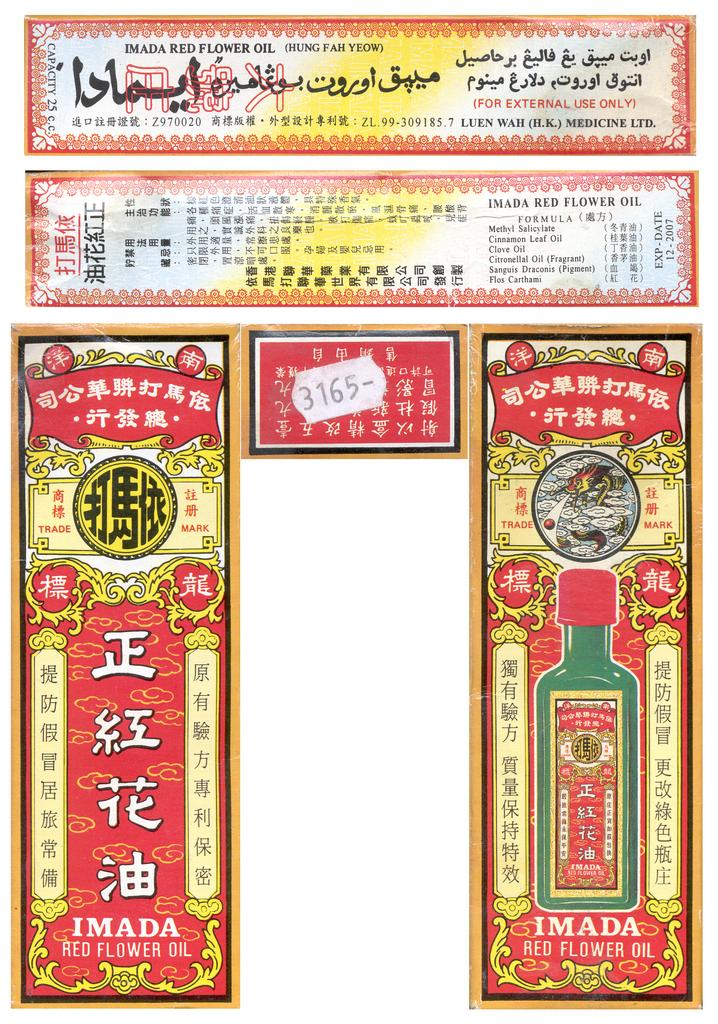<image>
Give a short and clear explanation of the subsequent image. Imada Red Flower Oil is the header of this label. 